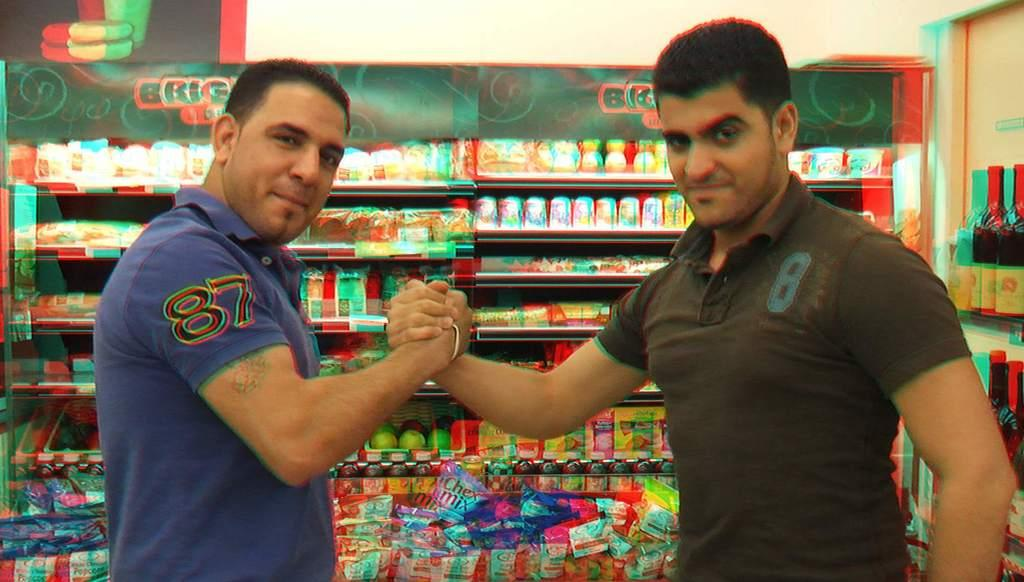Provide a one-sentence caption for the provided image. two men wearing shirts with numbers on them, with one being 87 and the other being 8. 